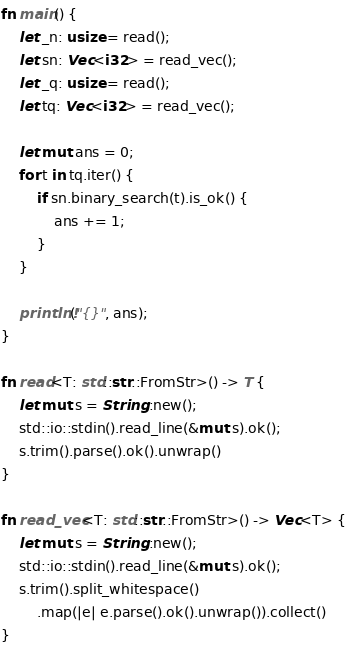Convert code to text. <code><loc_0><loc_0><loc_500><loc_500><_Rust_>

fn main() {
    let _n: usize = read();
    let sn: Vec<i32> = read_vec();
    let _q: usize = read();
    let tq: Vec<i32> = read_vec();

    let mut ans = 0;
    for t in tq.iter() {
        if sn.binary_search(t).is_ok() {
            ans += 1;
        }
    }    

    println!("{}", ans);
}

fn read<T: std::str::FromStr>() -> T {
    let mut s = String::new();
    std::io::stdin().read_line(&mut s).ok();
    s.trim().parse().ok().unwrap()
}

fn read_vec<T: std::str::FromStr>() -> Vec<T> {
    let mut s = String::new();
    std::io::stdin().read_line(&mut s).ok();
    s.trim().split_whitespace()
        .map(|e| e.parse().ok().unwrap()).collect()
}

</code> 